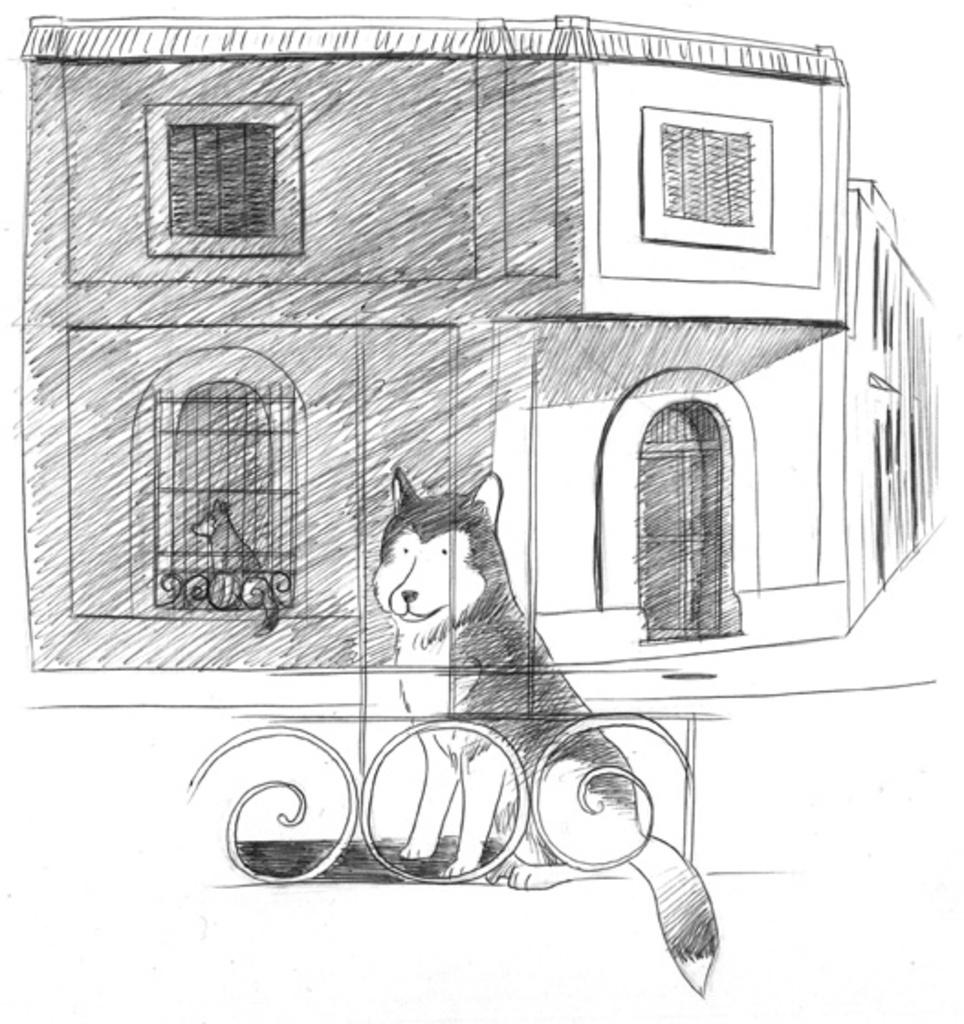What is depicted in the sketch in the image? The image contains a sketch of two dogs and a building. What color is the sketch in the image? The image is black and white in color. How many clovers can be seen in the image? There are no clovers present in the image; it contains a sketch of two dogs and a building. What type of neck is visible in the image? There is no neck visible in the image, as it contains a sketch of two dogs and a building. 